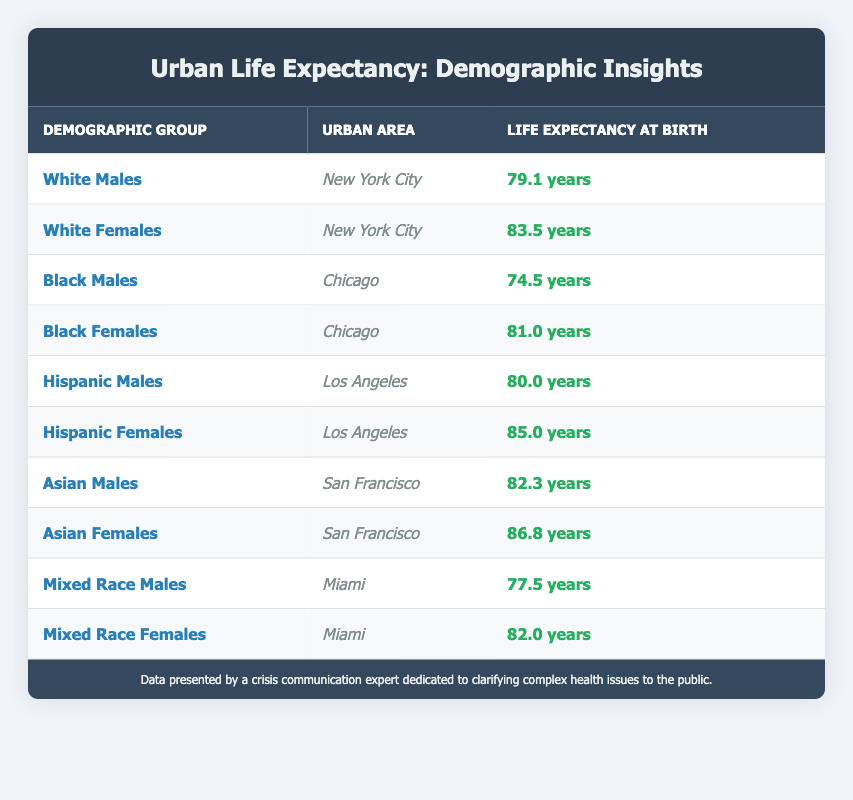What is the life expectancy at birth for White Females in New York City? The table directly states that the life expectancy at birth for White Females in New York City is 83.5 years.
Answer: 83.5 years What is the life expectancy at birth for Black Males in Chicago? According to the table, Black Males in Chicago have a life expectancy at birth of 74.5 years.
Answer: 74.5 years Which demographic group has the highest life expectancy at birth in Los Angeles? The table indicates that Hispanic Females in Los Angeles have the highest life expectancy at birth, recorded at 85.0 years.
Answer: Hispanic Females What is the difference in life expectancy at birth between Asian Females and Black Females? The life expectancy for Asian Females is 86.8 years, while for Black Females, it is 81.0 years. The difference is calculated as 86.8 - 81.0 = 5.8 years.
Answer: 5.8 years Is the life expectancy at birth for Mixed Race Females higher than that for White Males? The life expectancy for Mixed Race Females is 82.0 years and for White Males is 79.1 years. Since 82.0 > 79.1, it is true that Mixed Race Females have a higher life expectancy at birth than White Males.
Answer: Yes What is the average life expectancy at birth for Hispanic individuals in Los Angeles? The life expectancy for Hispanic Males is 80.0 years and for Hispanic Females is 85.0 years. The average is calculated as (80.0 + 85.0) / 2 = 82.5 years.
Answer: 82.5 years Which demographic group has the lowest life expectancy at birth, and what is that value? Upon reviewing the data, Black Males in Chicago have the lowest life expectancy at birth at 74.5 years.
Answer: Black Males, 74.5 years How does the life expectancy at birth for Asian Males compare to that for Mixed Race Males? Asian Males have a life expectancy at birth of 82.3 years, while Mixed Race Males have 77.5 years. Since 82.3 > 77.5, Asian Males have a higher life expectancy.
Answer: Asian Males have a higher life expectancy What is the total life expectancy at birth for all demographic groups in Miami? The life expectancy at birth for Mixed Race Males in Miami is 77.5 years and for Mixed Race Females is 82.0 years. The total is calculated as 77.5 + 82.0 = 159.5 years.
Answer: 159.5 years 